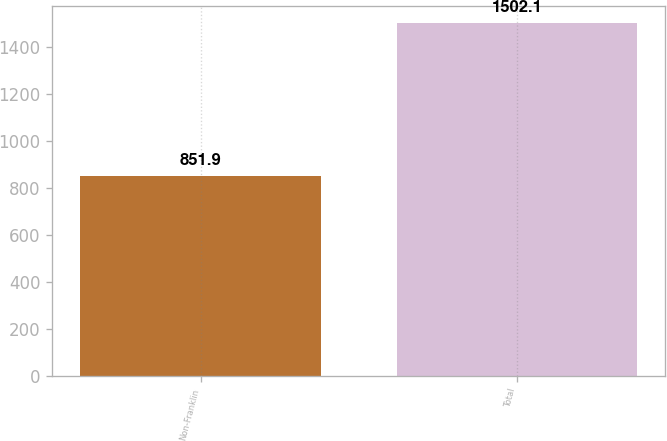Convert chart. <chart><loc_0><loc_0><loc_500><loc_500><bar_chart><fcel>Non-Franklin<fcel>Total<nl><fcel>851.9<fcel>1502.1<nl></chart> 